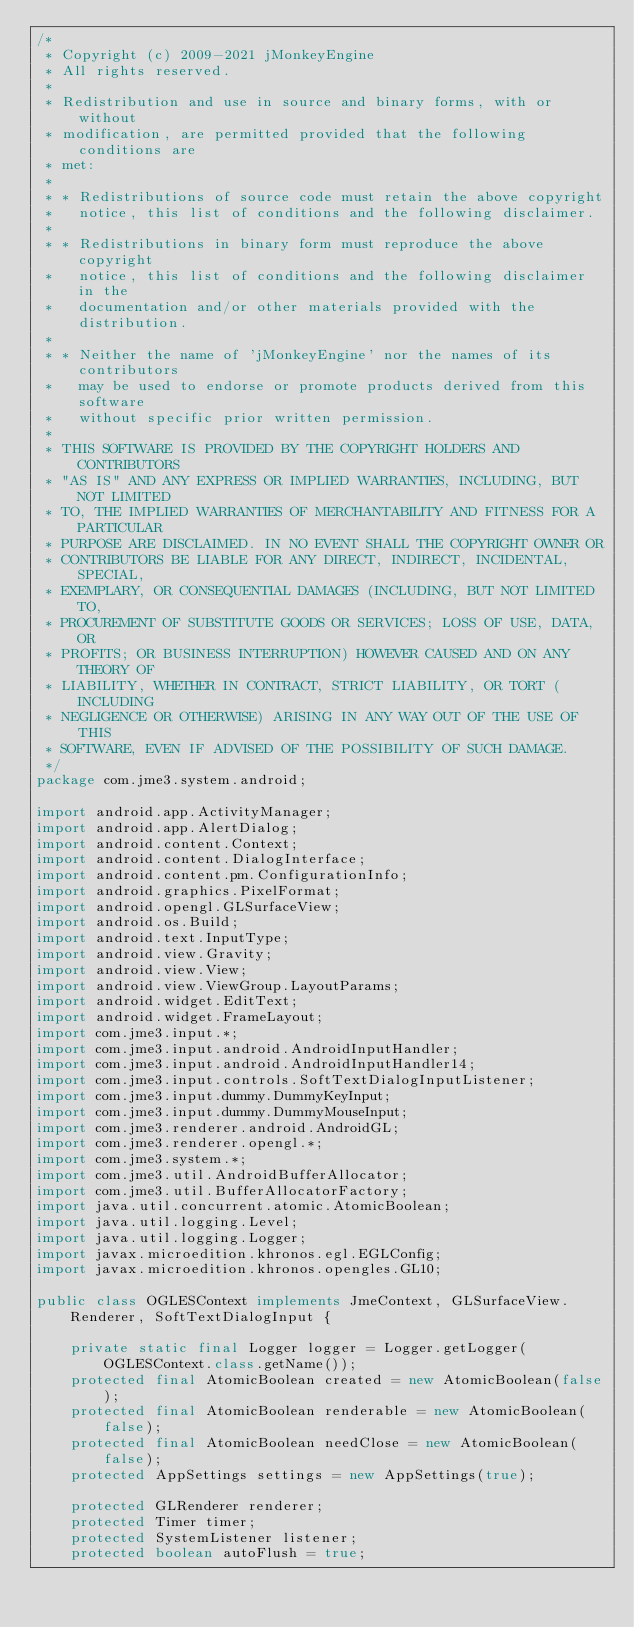Convert code to text. <code><loc_0><loc_0><loc_500><loc_500><_Java_>/*
 * Copyright (c) 2009-2021 jMonkeyEngine
 * All rights reserved.
 *
 * Redistribution and use in source and binary forms, with or without
 * modification, are permitted provided that the following conditions are
 * met:
 *
 * * Redistributions of source code must retain the above copyright
 *   notice, this list of conditions and the following disclaimer.
 *
 * * Redistributions in binary form must reproduce the above copyright
 *   notice, this list of conditions and the following disclaimer in the
 *   documentation and/or other materials provided with the distribution.
 *
 * * Neither the name of 'jMonkeyEngine' nor the names of its contributors
 *   may be used to endorse or promote products derived from this software
 *   without specific prior written permission.
 *
 * THIS SOFTWARE IS PROVIDED BY THE COPYRIGHT HOLDERS AND CONTRIBUTORS
 * "AS IS" AND ANY EXPRESS OR IMPLIED WARRANTIES, INCLUDING, BUT NOT LIMITED
 * TO, THE IMPLIED WARRANTIES OF MERCHANTABILITY AND FITNESS FOR A PARTICULAR
 * PURPOSE ARE DISCLAIMED. IN NO EVENT SHALL THE COPYRIGHT OWNER OR
 * CONTRIBUTORS BE LIABLE FOR ANY DIRECT, INDIRECT, INCIDENTAL, SPECIAL,
 * EXEMPLARY, OR CONSEQUENTIAL DAMAGES (INCLUDING, BUT NOT LIMITED TO,
 * PROCUREMENT OF SUBSTITUTE GOODS OR SERVICES; LOSS OF USE, DATA, OR
 * PROFITS; OR BUSINESS INTERRUPTION) HOWEVER CAUSED AND ON ANY THEORY OF
 * LIABILITY, WHETHER IN CONTRACT, STRICT LIABILITY, OR TORT (INCLUDING
 * NEGLIGENCE OR OTHERWISE) ARISING IN ANY WAY OUT OF THE USE OF THIS
 * SOFTWARE, EVEN IF ADVISED OF THE POSSIBILITY OF SUCH DAMAGE.
 */
package com.jme3.system.android;

import android.app.ActivityManager;
import android.app.AlertDialog;
import android.content.Context;
import android.content.DialogInterface;
import android.content.pm.ConfigurationInfo;
import android.graphics.PixelFormat;
import android.opengl.GLSurfaceView;
import android.os.Build;
import android.text.InputType;
import android.view.Gravity;
import android.view.View;
import android.view.ViewGroup.LayoutParams;
import android.widget.EditText;
import android.widget.FrameLayout;
import com.jme3.input.*;
import com.jme3.input.android.AndroidInputHandler;
import com.jme3.input.android.AndroidInputHandler14;
import com.jme3.input.controls.SoftTextDialogInputListener;
import com.jme3.input.dummy.DummyKeyInput;
import com.jme3.input.dummy.DummyMouseInput;
import com.jme3.renderer.android.AndroidGL;
import com.jme3.renderer.opengl.*;
import com.jme3.system.*;
import com.jme3.util.AndroidBufferAllocator;
import com.jme3.util.BufferAllocatorFactory;
import java.util.concurrent.atomic.AtomicBoolean;
import java.util.logging.Level;
import java.util.logging.Logger;
import javax.microedition.khronos.egl.EGLConfig;
import javax.microedition.khronos.opengles.GL10;

public class OGLESContext implements JmeContext, GLSurfaceView.Renderer, SoftTextDialogInput {

    private static final Logger logger = Logger.getLogger(OGLESContext.class.getName());
    protected final AtomicBoolean created = new AtomicBoolean(false);
    protected final AtomicBoolean renderable = new AtomicBoolean(false);
    protected final AtomicBoolean needClose = new AtomicBoolean(false);
    protected AppSettings settings = new AppSettings(true);

    protected GLRenderer renderer;
    protected Timer timer;
    protected SystemListener listener;
    protected boolean autoFlush = true;</code> 